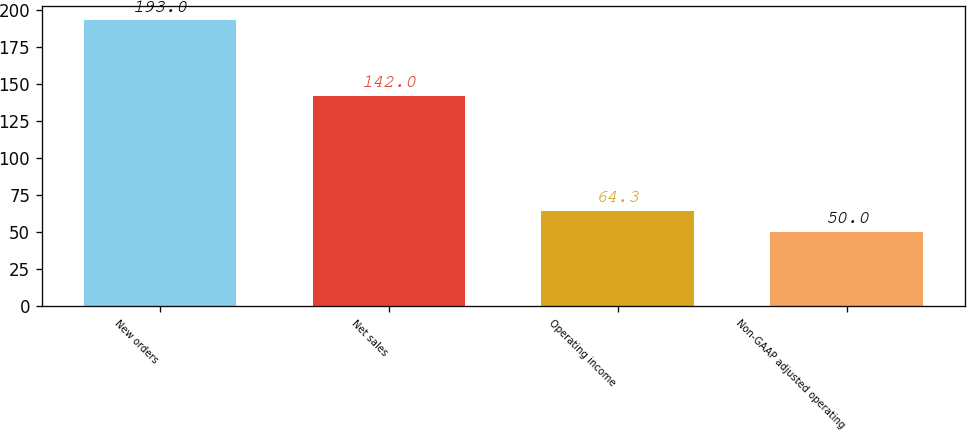<chart> <loc_0><loc_0><loc_500><loc_500><bar_chart><fcel>New orders<fcel>Net sales<fcel>Operating income<fcel>Non-GAAP adjusted operating<nl><fcel>193<fcel>142<fcel>64.3<fcel>50<nl></chart> 